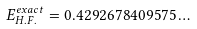Convert formula to latex. <formula><loc_0><loc_0><loc_500><loc_500>E _ { H . F . } ^ { e x a c t } = 0 . 4 2 9 2 6 7 8 4 0 9 5 7 5 \dots</formula> 